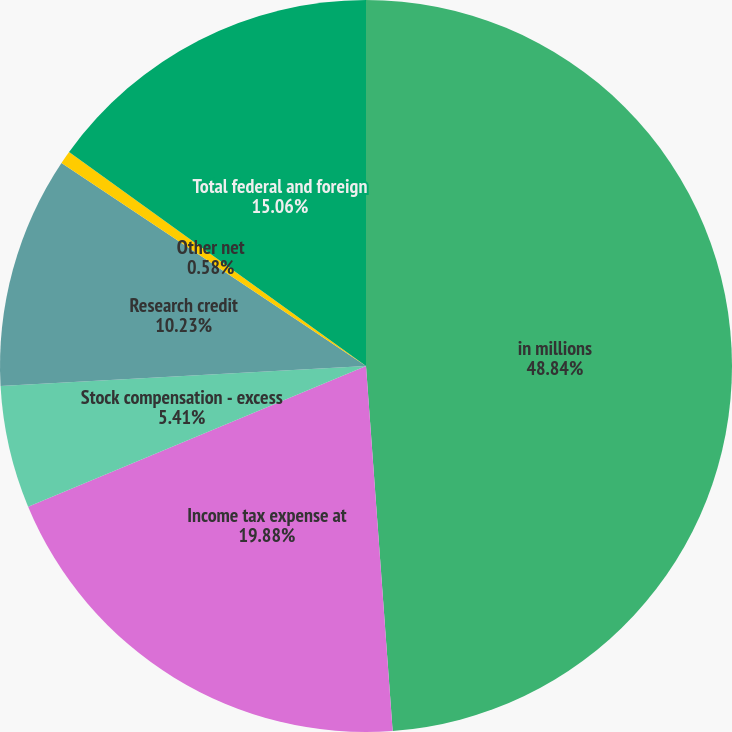Convert chart to OTSL. <chart><loc_0><loc_0><loc_500><loc_500><pie_chart><fcel>in millions<fcel>Income tax expense at<fcel>Stock compensation - excess<fcel>Research credit<fcel>Other net<fcel>Total federal and foreign<nl><fcel>48.84%<fcel>19.88%<fcel>5.41%<fcel>10.23%<fcel>0.58%<fcel>15.06%<nl></chart> 